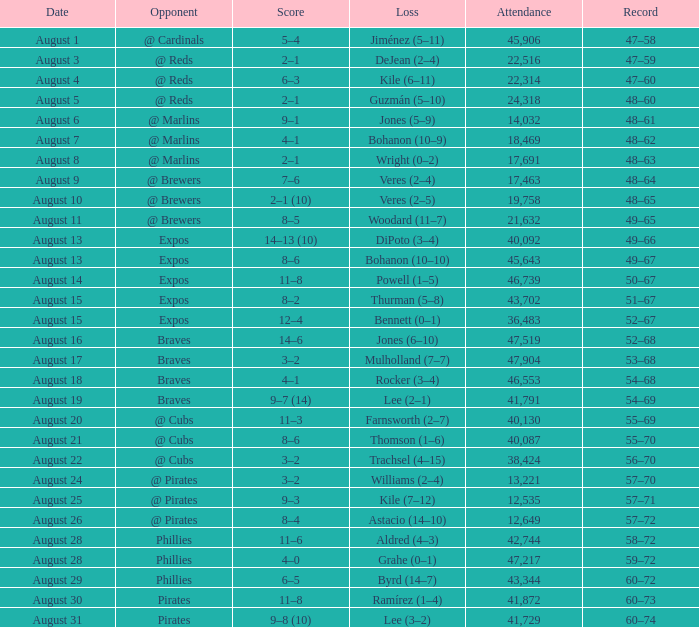What is the lowest attendance total on August 26? 12649.0. 